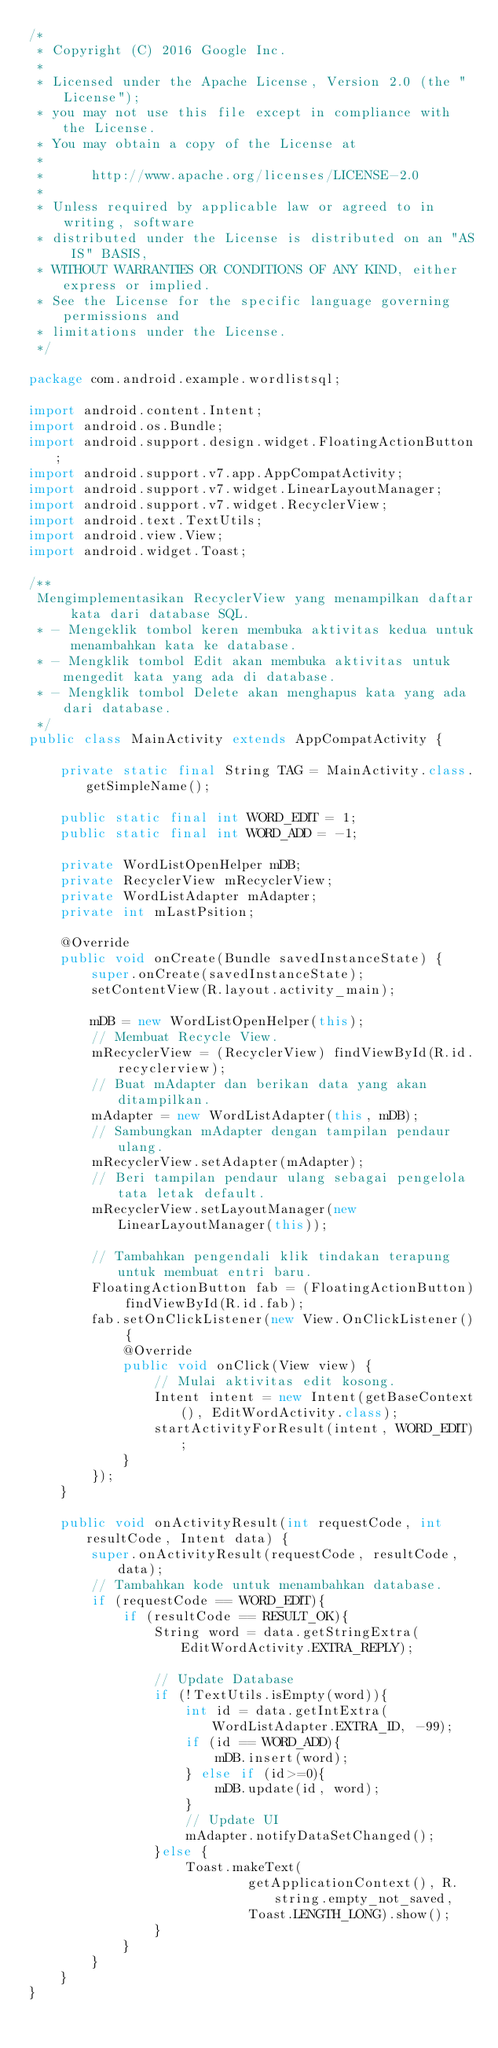Convert code to text. <code><loc_0><loc_0><loc_500><loc_500><_Java_>/*
 * Copyright (C) 2016 Google Inc.
 *
 * Licensed under the Apache License, Version 2.0 (the "License");
 * you may not use this file except in compliance with the License.
 * You may obtain a copy of the License at
 *
 *      http://www.apache.org/licenses/LICENSE-2.0
 *
 * Unless required by applicable law or agreed to in writing, software
 * distributed under the License is distributed on an "AS IS" BASIS,
 * WITHOUT WARRANTIES OR CONDITIONS OF ANY KIND, either express or implied.
 * See the License for the specific language governing permissions and
 * limitations under the License.
 */

package com.android.example.wordlistsql;

import android.content.Intent;
import android.os.Bundle;
import android.support.design.widget.FloatingActionButton;
import android.support.v7.app.AppCompatActivity;
import android.support.v7.widget.LinearLayoutManager;
import android.support.v7.widget.RecyclerView;
import android.text.TextUtils;
import android.view.View;
import android.widget.Toast;

/**
 Mengimplementasikan RecyclerView yang menampilkan daftar kata dari database SQL.
 * - Mengeklik tombol keren membuka aktivitas kedua untuk menambahkan kata ke database.
 * - Mengklik tombol Edit akan membuka aktivitas untuk mengedit kata yang ada di database.
 * - Mengklik tombol Delete akan menghapus kata yang ada dari database.
 */
public class MainActivity extends AppCompatActivity {

    private static final String TAG = MainActivity.class.getSimpleName();

    public static final int WORD_EDIT = 1;
    public static final int WORD_ADD = -1;

    private WordListOpenHelper mDB;
    private RecyclerView mRecyclerView;
    private WordListAdapter mAdapter;
    private int mLastPsition;

    @Override
    public void onCreate(Bundle savedInstanceState) {
        super.onCreate(savedInstanceState);
        setContentView(R.layout.activity_main);

        mDB = new WordListOpenHelper(this);
        // Membuat Recycle View.
        mRecyclerView = (RecyclerView) findViewById(R.id.recyclerview);
        // Buat mAdapter dan berikan data yang akan ditampilkan.
        mAdapter = new WordListAdapter(this, mDB);
        // Sambungkan mAdapter dengan tampilan pendaur ulang.
        mRecyclerView.setAdapter(mAdapter);
        // Beri tampilan pendaur ulang sebagai pengelola tata letak default.
        mRecyclerView.setLayoutManager(new LinearLayoutManager(this));

        // Tambahkan pengendali klik tindakan terapung untuk membuat entri baru.
        FloatingActionButton fab = (FloatingActionButton) findViewById(R.id.fab);
        fab.setOnClickListener(new View.OnClickListener() {
            @Override
            public void onClick(View view) {
                // Mulai aktivitas edit kosong.
                Intent intent = new Intent(getBaseContext(), EditWordActivity.class);
                startActivityForResult(intent, WORD_EDIT);
            }
        });
    }

    public void onActivityResult(int requestCode, int resultCode, Intent data) {
        super.onActivityResult(requestCode, resultCode, data);
        // Tambahkan kode untuk menambahkan database.
        if (requestCode == WORD_EDIT){
            if (resultCode == RESULT_OK){
                String word = data.getStringExtra(EditWordActivity.EXTRA_REPLY);

                // Update Database
                if (!TextUtils.isEmpty(word)){
                    int id = data.getIntExtra(WordListAdapter.EXTRA_ID, -99);
                    if (id == WORD_ADD){
                        mDB.insert(word);
                    } else if (id>=0){
                        mDB.update(id, word);
                    }
                    // Update UI
                    mAdapter.notifyDataSetChanged();
                }else {
                    Toast.makeText(
                            getApplicationContext(), R.string.empty_not_saved,
                            Toast.LENGTH_LONG).show();
                }
            }
        }
    }
}</code> 